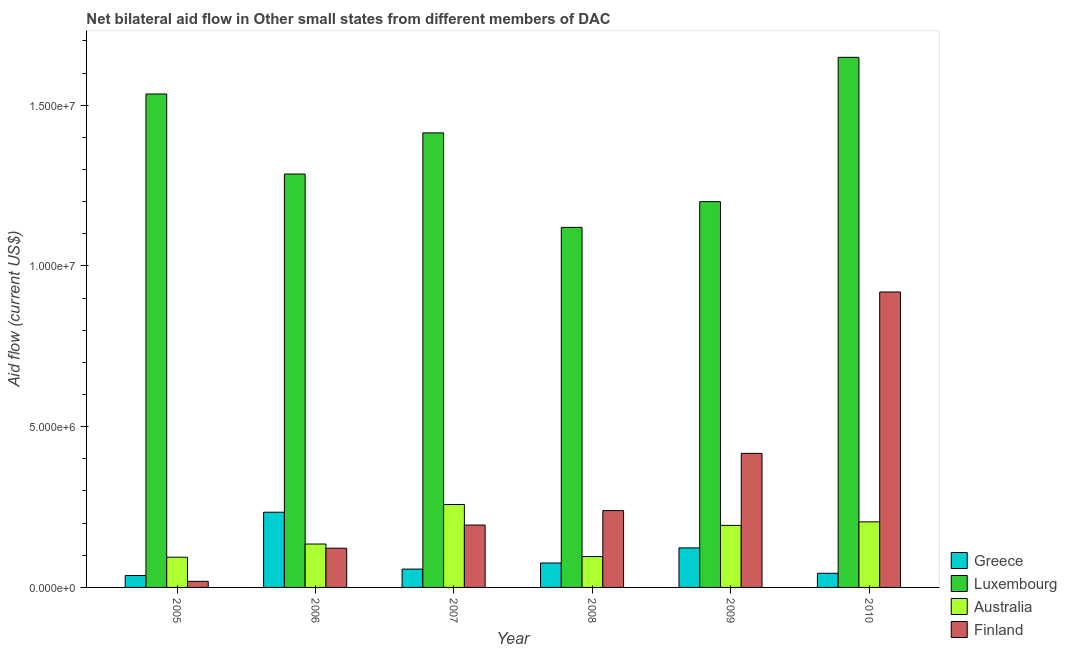How many different coloured bars are there?
Ensure brevity in your answer.  4. Are the number of bars per tick equal to the number of legend labels?
Provide a short and direct response. Yes. Are the number of bars on each tick of the X-axis equal?
Provide a succinct answer. Yes. How many bars are there on the 3rd tick from the left?
Ensure brevity in your answer.  4. How many bars are there on the 5th tick from the right?
Ensure brevity in your answer.  4. What is the label of the 4th group of bars from the left?
Keep it short and to the point. 2008. What is the amount of aid given by australia in 2009?
Provide a succinct answer. 1.93e+06. Across all years, what is the maximum amount of aid given by finland?
Your response must be concise. 9.19e+06. Across all years, what is the minimum amount of aid given by australia?
Offer a terse response. 9.40e+05. In which year was the amount of aid given by finland minimum?
Give a very brief answer. 2005. What is the total amount of aid given by finland in the graph?
Make the answer very short. 1.91e+07. What is the difference between the amount of aid given by finland in 2005 and that in 2010?
Your response must be concise. -9.00e+06. What is the difference between the amount of aid given by greece in 2005 and the amount of aid given by luxembourg in 2007?
Your answer should be compact. -2.00e+05. What is the average amount of aid given by finland per year?
Ensure brevity in your answer.  3.18e+06. What is the ratio of the amount of aid given by greece in 2008 to that in 2010?
Offer a terse response. 1.73. What is the difference between the highest and the second highest amount of aid given by greece?
Offer a terse response. 1.11e+06. What is the difference between the highest and the lowest amount of aid given by australia?
Make the answer very short. 1.64e+06. Is the sum of the amount of aid given by finland in 2006 and 2009 greater than the maximum amount of aid given by greece across all years?
Make the answer very short. No. What does the 2nd bar from the right in 2006 represents?
Your answer should be compact. Australia. What is the difference between two consecutive major ticks on the Y-axis?
Offer a very short reply. 5.00e+06. Are the values on the major ticks of Y-axis written in scientific E-notation?
Offer a terse response. Yes. Does the graph contain any zero values?
Your response must be concise. No. Where does the legend appear in the graph?
Your answer should be very brief. Bottom right. How many legend labels are there?
Your answer should be very brief. 4. How are the legend labels stacked?
Your answer should be very brief. Vertical. What is the title of the graph?
Offer a very short reply. Net bilateral aid flow in Other small states from different members of DAC. Does "Regional development banks" appear as one of the legend labels in the graph?
Make the answer very short. No. What is the label or title of the X-axis?
Make the answer very short. Year. What is the Aid flow (current US$) of Greece in 2005?
Your answer should be compact. 3.70e+05. What is the Aid flow (current US$) of Luxembourg in 2005?
Your response must be concise. 1.54e+07. What is the Aid flow (current US$) in Australia in 2005?
Your answer should be very brief. 9.40e+05. What is the Aid flow (current US$) in Finland in 2005?
Give a very brief answer. 1.90e+05. What is the Aid flow (current US$) in Greece in 2006?
Keep it short and to the point. 2.34e+06. What is the Aid flow (current US$) of Luxembourg in 2006?
Offer a very short reply. 1.29e+07. What is the Aid flow (current US$) of Australia in 2006?
Offer a terse response. 1.35e+06. What is the Aid flow (current US$) in Finland in 2006?
Offer a very short reply. 1.22e+06. What is the Aid flow (current US$) of Greece in 2007?
Your response must be concise. 5.70e+05. What is the Aid flow (current US$) in Luxembourg in 2007?
Provide a short and direct response. 1.41e+07. What is the Aid flow (current US$) in Australia in 2007?
Make the answer very short. 2.58e+06. What is the Aid flow (current US$) in Finland in 2007?
Provide a succinct answer. 1.94e+06. What is the Aid flow (current US$) of Greece in 2008?
Your response must be concise. 7.60e+05. What is the Aid flow (current US$) in Luxembourg in 2008?
Ensure brevity in your answer.  1.12e+07. What is the Aid flow (current US$) of Australia in 2008?
Your answer should be very brief. 9.60e+05. What is the Aid flow (current US$) of Finland in 2008?
Your answer should be very brief. 2.39e+06. What is the Aid flow (current US$) of Greece in 2009?
Offer a very short reply. 1.23e+06. What is the Aid flow (current US$) in Luxembourg in 2009?
Ensure brevity in your answer.  1.20e+07. What is the Aid flow (current US$) in Australia in 2009?
Keep it short and to the point. 1.93e+06. What is the Aid flow (current US$) in Finland in 2009?
Provide a short and direct response. 4.17e+06. What is the Aid flow (current US$) in Luxembourg in 2010?
Your answer should be compact. 1.65e+07. What is the Aid flow (current US$) in Australia in 2010?
Your answer should be compact. 2.04e+06. What is the Aid flow (current US$) of Finland in 2010?
Give a very brief answer. 9.19e+06. Across all years, what is the maximum Aid flow (current US$) in Greece?
Your response must be concise. 2.34e+06. Across all years, what is the maximum Aid flow (current US$) of Luxembourg?
Your answer should be very brief. 1.65e+07. Across all years, what is the maximum Aid flow (current US$) of Australia?
Offer a very short reply. 2.58e+06. Across all years, what is the maximum Aid flow (current US$) in Finland?
Provide a succinct answer. 9.19e+06. Across all years, what is the minimum Aid flow (current US$) of Greece?
Offer a terse response. 3.70e+05. Across all years, what is the minimum Aid flow (current US$) of Luxembourg?
Offer a very short reply. 1.12e+07. Across all years, what is the minimum Aid flow (current US$) in Australia?
Give a very brief answer. 9.40e+05. What is the total Aid flow (current US$) in Greece in the graph?
Provide a succinct answer. 5.71e+06. What is the total Aid flow (current US$) in Luxembourg in the graph?
Give a very brief answer. 8.20e+07. What is the total Aid flow (current US$) of Australia in the graph?
Your answer should be very brief. 9.80e+06. What is the total Aid flow (current US$) in Finland in the graph?
Your answer should be compact. 1.91e+07. What is the difference between the Aid flow (current US$) in Greece in 2005 and that in 2006?
Your answer should be compact. -1.97e+06. What is the difference between the Aid flow (current US$) of Luxembourg in 2005 and that in 2006?
Ensure brevity in your answer.  2.49e+06. What is the difference between the Aid flow (current US$) in Australia in 2005 and that in 2006?
Keep it short and to the point. -4.10e+05. What is the difference between the Aid flow (current US$) of Finland in 2005 and that in 2006?
Keep it short and to the point. -1.03e+06. What is the difference between the Aid flow (current US$) of Greece in 2005 and that in 2007?
Give a very brief answer. -2.00e+05. What is the difference between the Aid flow (current US$) of Luxembourg in 2005 and that in 2007?
Ensure brevity in your answer.  1.21e+06. What is the difference between the Aid flow (current US$) of Australia in 2005 and that in 2007?
Offer a terse response. -1.64e+06. What is the difference between the Aid flow (current US$) of Finland in 2005 and that in 2007?
Give a very brief answer. -1.75e+06. What is the difference between the Aid flow (current US$) in Greece in 2005 and that in 2008?
Ensure brevity in your answer.  -3.90e+05. What is the difference between the Aid flow (current US$) in Luxembourg in 2005 and that in 2008?
Keep it short and to the point. 4.15e+06. What is the difference between the Aid flow (current US$) in Finland in 2005 and that in 2008?
Your answer should be compact. -2.20e+06. What is the difference between the Aid flow (current US$) of Greece in 2005 and that in 2009?
Your answer should be compact. -8.60e+05. What is the difference between the Aid flow (current US$) of Luxembourg in 2005 and that in 2009?
Your answer should be compact. 3.35e+06. What is the difference between the Aid flow (current US$) of Australia in 2005 and that in 2009?
Your answer should be very brief. -9.90e+05. What is the difference between the Aid flow (current US$) in Finland in 2005 and that in 2009?
Provide a short and direct response. -3.98e+06. What is the difference between the Aid flow (current US$) of Greece in 2005 and that in 2010?
Provide a succinct answer. -7.00e+04. What is the difference between the Aid flow (current US$) of Luxembourg in 2005 and that in 2010?
Your answer should be very brief. -1.14e+06. What is the difference between the Aid flow (current US$) of Australia in 2005 and that in 2010?
Your answer should be compact. -1.10e+06. What is the difference between the Aid flow (current US$) of Finland in 2005 and that in 2010?
Ensure brevity in your answer.  -9.00e+06. What is the difference between the Aid flow (current US$) in Greece in 2006 and that in 2007?
Provide a short and direct response. 1.77e+06. What is the difference between the Aid flow (current US$) in Luxembourg in 2006 and that in 2007?
Make the answer very short. -1.28e+06. What is the difference between the Aid flow (current US$) of Australia in 2006 and that in 2007?
Your response must be concise. -1.23e+06. What is the difference between the Aid flow (current US$) of Finland in 2006 and that in 2007?
Give a very brief answer. -7.20e+05. What is the difference between the Aid flow (current US$) of Greece in 2006 and that in 2008?
Your response must be concise. 1.58e+06. What is the difference between the Aid flow (current US$) of Luxembourg in 2006 and that in 2008?
Your response must be concise. 1.66e+06. What is the difference between the Aid flow (current US$) in Finland in 2006 and that in 2008?
Your answer should be very brief. -1.17e+06. What is the difference between the Aid flow (current US$) in Greece in 2006 and that in 2009?
Make the answer very short. 1.11e+06. What is the difference between the Aid flow (current US$) of Luxembourg in 2006 and that in 2009?
Provide a short and direct response. 8.60e+05. What is the difference between the Aid flow (current US$) of Australia in 2006 and that in 2009?
Offer a terse response. -5.80e+05. What is the difference between the Aid flow (current US$) in Finland in 2006 and that in 2009?
Ensure brevity in your answer.  -2.95e+06. What is the difference between the Aid flow (current US$) of Greece in 2006 and that in 2010?
Your answer should be very brief. 1.90e+06. What is the difference between the Aid flow (current US$) in Luxembourg in 2006 and that in 2010?
Your answer should be very brief. -3.63e+06. What is the difference between the Aid flow (current US$) of Australia in 2006 and that in 2010?
Provide a short and direct response. -6.90e+05. What is the difference between the Aid flow (current US$) of Finland in 2006 and that in 2010?
Your response must be concise. -7.97e+06. What is the difference between the Aid flow (current US$) of Luxembourg in 2007 and that in 2008?
Keep it short and to the point. 2.94e+06. What is the difference between the Aid flow (current US$) of Australia in 2007 and that in 2008?
Offer a very short reply. 1.62e+06. What is the difference between the Aid flow (current US$) in Finland in 2007 and that in 2008?
Offer a terse response. -4.50e+05. What is the difference between the Aid flow (current US$) of Greece in 2007 and that in 2009?
Keep it short and to the point. -6.60e+05. What is the difference between the Aid flow (current US$) of Luxembourg in 2007 and that in 2009?
Ensure brevity in your answer.  2.14e+06. What is the difference between the Aid flow (current US$) of Australia in 2007 and that in 2009?
Give a very brief answer. 6.50e+05. What is the difference between the Aid flow (current US$) in Finland in 2007 and that in 2009?
Your response must be concise. -2.23e+06. What is the difference between the Aid flow (current US$) of Luxembourg in 2007 and that in 2010?
Your answer should be compact. -2.35e+06. What is the difference between the Aid flow (current US$) in Australia in 2007 and that in 2010?
Ensure brevity in your answer.  5.40e+05. What is the difference between the Aid flow (current US$) in Finland in 2007 and that in 2010?
Offer a terse response. -7.25e+06. What is the difference between the Aid flow (current US$) of Greece in 2008 and that in 2009?
Provide a short and direct response. -4.70e+05. What is the difference between the Aid flow (current US$) of Luxembourg in 2008 and that in 2009?
Keep it short and to the point. -8.00e+05. What is the difference between the Aid flow (current US$) in Australia in 2008 and that in 2009?
Your answer should be compact. -9.70e+05. What is the difference between the Aid flow (current US$) of Finland in 2008 and that in 2009?
Ensure brevity in your answer.  -1.78e+06. What is the difference between the Aid flow (current US$) in Luxembourg in 2008 and that in 2010?
Give a very brief answer. -5.29e+06. What is the difference between the Aid flow (current US$) of Australia in 2008 and that in 2010?
Your answer should be compact. -1.08e+06. What is the difference between the Aid flow (current US$) of Finland in 2008 and that in 2010?
Offer a very short reply. -6.80e+06. What is the difference between the Aid flow (current US$) in Greece in 2009 and that in 2010?
Your answer should be compact. 7.90e+05. What is the difference between the Aid flow (current US$) in Luxembourg in 2009 and that in 2010?
Offer a very short reply. -4.49e+06. What is the difference between the Aid flow (current US$) of Australia in 2009 and that in 2010?
Offer a very short reply. -1.10e+05. What is the difference between the Aid flow (current US$) in Finland in 2009 and that in 2010?
Make the answer very short. -5.02e+06. What is the difference between the Aid flow (current US$) in Greece in 2005 and the Aid flow (current US$) in Luxembourg in 2006?
Your answer should be very brief. -1.25e+07. What is the difference between the Aid flow (current US$) in Greece in 2005 and the Aid flow (current US$) in Australia in 2006?
Ensure brevity in your answer.  -9.80e+05. What is the difference between the Aid flow (current US$) in Greece in 2005 and the Aid flow (current US$) in Finland in 2006?
Offer a terse response. -8.50e+05. What is the difference between the Aid flow (current US$) of Luxembourg in 2005 and the Aid flow (current US$) of Australia in 2006?
Provide a short and direct response. 1.40e+07. What is the difference between the Aid flow (current US$) in Luxembourg in 2005 and the Aid flow (current US$) in Finland in 2006?
Ensure brevity in your answer.  1.41e+07. What is the difference between the Aid flow (current US$) in Australia in 2005 and the Aid flow (current US$) in Finland in 2006?
Provide a short and direct response. -2.80e+05. What is the difference between the Aid flow (current US$) in Greece in 2005 and the Aid flow (current US$) in Luxembourg in 2007?
Offer a terse response. -1.38e+07. What is the difference between the Aid flow (current US$) in Greece in 2005 and the Aid flow (current US$) in Australia in 2007?
Provide a short and direct response. -2.21e+06. What is the difference between the Aid flow (current US$) of Greece in 2005 and the Aid flow (current US$) of Finland in 2007?
Ensure brevity in your answer.  -1.57e+06. What is the difference between the Aid flow (current US$) in Luxembourg in 2005 and the Aid flow (current US$) in Australia in 2007?
Make the answer very short. 1.28e+07. What is the difference between the Aid flow (current US$) in Luxembourg in 2005 and the Aid flow (current US$) in Finland in 2007?
Provide a succinct answer. 1.34e+07. What is the difference between the Aid flow (current US$) in Greece in 2005 and the Aid flow (current US$) in Luxembourg in 2008?
Give a very brief answer. -1.08e+07. What is the difference between the Aid flow (current US$) in Greece in 2005 and the Aid flow (current US$) in Australia in 2008?
Give a very brief answer. -5.90e+05. What is the difference between the Aid flow (current US$) of Greece in 2005 and the Aid flow (current US$) of Finland in 2008?
Provide a succinct answer. -2.02e+06. What is the difference between the Aid flow (current US$) in Luxembourg in 2005 and the Aid flow (current US$) in Australia in 2008?
Provide a succinct answer. 1.44e+07. What is the difference between the Aid flow (current US$) of Luxembourg in 2005 and the Aid flow (current US$) of Finland in 2008?
Keep it short and to the point. 1.30e+07. What is the difference between the Aid flow (current US$) of Australia in 2005 and the Aid flow (current US$) of Finland in 2008?
Provide a short and direct response. -1.45e+06. What is the difference between the Aid flow (current US$) in Greece in 2005 and the Aid flow (current US$) in Luxembourg in 2009?
Your answer should be compact. -1.16e+07. What is the difference between the Aid flow (current US$) in Greece in 2005 and the Aid flow (current US$) in Australia in 2009?
Your answer should be very brief. -1.56e+06. What is the difference between the Aid flow (current US$) in Greece in 2005 and the Aid flow (current US$) in Finland in 2009?
Offer a terse response. -3.80e+06. What is the difference between the Aid flow (current US$) in Luxembourg in 2005 and the Aid flow (current US$) in Australia in 2009?
Keep it short and to the point. 1.34e+07. What is the difference between the Aid flow (current US$) in Luxembourg in 2005 and the Aid flow (current US$) in Finland in 2009?
Keep it short and to the point. 1.12e+07. What is the difference between the Aid flow (current US$) in Australia in 2005 and the Aid flow (current US$) in Finland in 2009?
Offer a terse response. -3.23e+06. What is the difference between the Aid flow (current US$) of Greece in 2005 and the Aid flow (current US$) of Luxembourg in 2010?
Offer a very short reply. -1.61e+07. What is the difference between the Aid flow (current US$) in Greece in 2005 and the Aid flow (current US$) in Australia in 2010?
Your response must be concise. -1.67e+06. What is the difference between the Aid flow (current US$) of Greece in 2005 and the Aid flow (current US$) of Finland in 2010?
Your response must be concise. -8.82e+06. What is the difference between the Aid flow (current US$) of Luxembourg in 2005 and the Aid flow (current US$) of Australia in 2010?
Keep it short and to the point. 1.33e+07. What is the difference between the Aid flow (current US$) in Luxembourg in 2005 and the Aid flow (current US$) in Finland in 2010?
Keep it short and to the point. 6.16e+06. What is the difference between the Aid flow (current US$) in Australia in 2005 and the Aid flow (current US$) in Finland in 2010?
Offer a very short reply. -8.25e+06. What is the difference between the Aid flow (current US$) of Greece in 2006 and the Aid flow (current US$) of Luxembourg in 2007?
Offer a very short reply. -1.18e+07. What is the difference between the Aid flow (current US$) of Greece in 2006 and the Aid flow (current US$) of Australia in 2007?
Your response must be concise. -2.40e+05. What is the difference between the Aid flow (current US$) of Greece in 2006 and the Aid flow (current US$) of Finland in 2007?
Ensure brevity in your answer.  4.00e+05. What is the difference between the Aid flow (current US$) in Luxembourg in 2006 and the Aid flow (current US$) in Australia in 2007?
Provide a short and direct response. 1.03e+07. What is the difference between the Aid flow (current US$) of Luxembourg in 2006 and the Aid flow (current US$) of Finland in 2007?
Offer a terse response. 1.09e+07. What is the difference between the Aid flow (current US$) of Australia in 2006 and the Aid flow (current US$) of Finland in 2007?
Keep it short and to the point. -5.90e+05. What is the difference between the Aid flow (current US$) of Greece in 2006 and the Aid flow (current US$) of Luxembourg in 2008?
Keep it short and to the point. -8.86e+06. What is the difference between the Aid flow (current US$) in Greece in 2006 and the Aid flow (current US$) in Australia in 2008?
Give a very brief answer. 1.38e+06. What is the difference between the Aid flow (current US$) of Greece in 2006 and the Aid flow (current US$) of Finland in 2008?
Provide a short and direct response. -5.00e+04. What is the difference between the Aid flow (current US$) of Luxembourg in 2006 and the Aid flow (current US$) of Australia in 2008?
Make the answer very short. 1.19e+07. What is the difference between the Aid flow (current US$) in Luxembourg in 2006 and the Aid flow (current US$) in Finland in 2008?
Make the answer very short. 1.05e+07. What is the difference between the Aid flow (current US$) of Australia in 2006 and the Aid flow (current US$) of Finland in 2008?
Provide a short and direct response. -1.04e+06. What is the difference between the Aid flow (current US$) in Greece in 2006 and the Aid flow (current US$) in Luxembourg in 2009?
Offer a very short reply. -9.66e+06. What is the difference between the Aid flow (current US$) of Greece in 2006 and the Aid flow (current US$) of Australia in 2009?
Ensure brevity in your answer.  4.10e+05. What is the difference between the Aid flow (current US$) of Greece in 2006 and the Aid flow (current US$) of Finland in 2009?
Ensure brevity in your answer.  -1.83e+06. What is the difference between the Aid flow (current US$) of Luxembourg in 2006 and the Aid flow (current US$) of Australia in 2009?
Offer a terse response. 1.09e+07. What is the difference between the Aid flow (current US$) in Luxembourg in 2006 and the Aid flow (current US$) in Finland in 2009?
Ensure brevity in your answer.  8.69e+06. What is the difference between the Aid flow (current US$) of Australia in 2006 and the Aid flow (current US$) of Finland in 2009?
Your answer should be compact. -2.82e+06. What is the difference between the Aid flow (current US$) in Greece in 2006 and the Aid flow (current US$) in Luxembourg in 2010?
Your answer should be compact. -1.42e+07. What is the difference between the Aid flow (current US$) in Greece in 2006 and the Aid flow (current US$) in Finland in 2010?
Your answer should be very brief. -6.85e+06. What is the difference between the Aid flow (current US$) of Luxembourg in 2006 and the Aid flow (current US$) of Australia in 2010?
Give a very brief answer. 1.08e+07. What is the difference between the Aid flow (current US$) in Luxembourg in 2006 and the Aid flow (current US$) in Finland in 2010?
Ensure brevity in your answer.  3.67e+06. What is the difference between the Aid flow (current US$) of Australia in 2006 and the Aid flow (current US$) of Finland in 2010?
Provide a short and direct response. -7.84e+06. What is the difference between the Aid flow (current US$) in Greece in 2007 and the Aid flow (current US$) in Luxembourg in 2008?
Make the answer very short. -1.06e+07. What is the difference between the Aid flow (current US$) of Greece in 2007 and the Aid flow (current US$) of Australia in 2008?
Your response must be concise. -3.90e+05. What is the difference between the Aid flow (current US$) of Greece in 2007 and the Aid flow (current US$) of Finland in 2008?
Keep it short and to the point. -1.82e+06. What is the difference between the Aid flow (current US$) in Luxembourg in 2007 and the Aid flow (current US$) in Australia in 2008?
Your answer should be very brief. 1.32e+07. What is the difference between the Aid flow (current US$) in Luxembourg in 2007 and the Aid flow (current US$) in Finland in 2008?
Your answer should be compact. 1.18e+07. What is the difference between the Aid flow (current US$) in Australia in 2007 and the Aid flow (current US$) in Finland in 2008?
Keep it short and to the point. 1.90e+05. What is the difference between the Aid flow (current US$) of Greece in 2007 and the Aid flow (current US$) of Luxembourg in 2009?
Give a very brief answer. -1.14e+07. What is the difference between the Aid flow (current US$) of Greece in 2007 and the Aid flow (current US$) of Australia in 2009?
Offer a very short reply. -1.36e+06. What is the difference between the Aid flow (current US$) in Greece in 2007 and the Aid flow (current US$) in Finland in 2009?
Keep it short and to the point. -3.60e+06. What is the difference between the Aid flow (current US$) in Luxembourg in 2007 and the Aid flow (current US$) in Australia in 2009?
Your response must be concise. 1.22e+07. What is the difference between the Aid flow (current US$) in Luxembourg in 2007 and the Aid flow (current US$) in Finland in 2009?
Your answer should be compact. 9.97e+06. What is the difference between the Aid flow (current US$) in Australia in 2007 and the Aid flow (current US$) in Finland in 2009?
Offer a terse response. -1.59e+06. What is the difference between the Aid flow (current US$) of Greece in 2007 and the Aid flow (current US$) of Luxembourg in 2010?
Keep it short and to the point. -1.59e+07. What is the difference between the Aid flow (current US$) of Greece in 2007 and the Aid flow (current US$) of Australia in 2010?
Your answer should be compact. -1.47e+06. What is the difference between the Aid flow (current US$) of Greece in 2007 and the Aid flow (current US$) of Finland in 2010?
Give a very brief answer. -8.62e+06. What is the difference between the Aid flow (current US$) in Luxembourg in 2007 and the Aid flow (current US$) in Australia in 2010?
Keep it short and to the point. 1.21e+07. What is the difference between the Aid flow (current US$) in Luxembourg in 2007 and the Aid flow (current US$) in Finland in 2010?
Offer a very short reply. 4.95e+06. What is the difference between the Aid flow (current US$) of Australia in 2007 and the Aid flow (current US$) of Finland in 2010?
Give a very brief answer. -6.61e+06. What is the difference between the Aid flow (current US$) of Greece in 2008 and the Aid flow (current US$) of Luxembourg in 2009?
Give a very brief answer. -1.12e+07. What is the difference between the Aid flow (current US$) of Greece in 2008 and the Aid flow (current US$) of Australia in 2009?
Your answer should be compact. -1.17e+06. What is the difference between the Aid flow (current US$) in Greece in 2008 and the Aid flow (current US$) in Finland in 2009?
Make the answer very short. -3.41e+06. What is the difference between the Aid flow (current US$) of Luxembourg in 2008 and the Aid flow (current US$) of Australia in 2009?
Give a very brief answer. 9.27e+06. What is the difference between the Aid flow (current US$) in Luxembourg in 2008 and the Aid flow (current US$) in Finland in 2009?
Provide a succinct answer. 7.03e+06. What is the difference between the Aid flow (current US$) of Australia in 2008 and the Aid flow (current US$) of Finland in 2009?
Give a very brief answer. -3.21e+06. What is the difference between the Aid flow (current US$) in Greece in 2008 and the Aid flow (current US$) in Luxembourg in 2010?
Provide a succinct answer. -1.57e+07. What is the difference between the Aid flow (current US$) of Greece in 2008 and the Aid flow (current US$) of Australia in 2010?
Keep it short and to the point. -1.28e+06. What is the difference between the Aid flow (current US$) of Greece in 2008 and the Aid flow (current US$) of Finland in 2010?
Provide a short and direct response. -8.43e+06. What is the difference between the Aid flow (current US$) in Luxembourg in 2008 and the Aid flow (current US$) in Australia in 2010?
Your answer should be very brief. 9.16e+06. What is the difference between the Aid flow (current US$) of Luxembourg in 2008 and the Aid flow (current US$) of Finland in 2010?
Offer a terse response. 2.01e+06. What is the difference between the Aid flow (current US$) of Australia in 2008 and the Aid flow (current US$) of Finland in 2010?
Provide a succinct answer. -8.23e+06. What is the difference between the Aid flow (current US$) in Greece in 2009 and the Aid flow (current US$) in Luxembourg in 2010?
Make the answer very short. -1.53e+07. What is the difference between the Aid flow (current US$) in Greece in 2009 and the Aid flow (current US$) in Australia in 2010?
Provide a short and direct response. -8.10e+05. What is the difference between the Aid flow (current US$) in Greece in 2009 and the Aid flow (current US$) in Finland in 2010?
Ensure brevity in your answer.  -7.96e+06. What is the difference between the Aid flow (current US$) in Luxembourg in 2009 and the Aid flow (current US$) in Australia in 2010?
Your answer should be compact. 9.96e+06. What is the difference between the Aid flow (current US$) of Luxembourg in 2009 and the Aid flow (current US$) of Finland in 2010?
Offer a terse response. 2.81e+06. What is the difference between the Aid flow (current US$) in Australia in 2009 and the Aid flow (current US$) in Finland in 2010?
Offer a very short reply. -7.26e+06. What is the average Aid flow (current US$) of Greece per year?
Provide a succinct answer. 9.52e+05. What is the average Aid flow (current US$) in Luxembourg per year?
Offer a terse response. 1.37e+07. What is the average Aid flow (current US$) in Australia per year?
Your answer should be compact. 1.63e+06. What is the average Aid flow (current US$) in Finland per year?
Give a very brief answer. 3.18e+06. In the year 2005, what is the difference between the Aid flow (current US$) in Greece and Aid flow (current US$) in Luxembourg?
Your answer should be very brief. -1.50e+07. In the year 2005, what is the difference between the Aid flow (current US$) in Greece and Aid flow (current US$) in Australia?
Give a very brief answer. -5.70e+05. In the year 2005, what is the difference between the Aid flow (current US$) in Greece and Aid flow (current US$) in Finland?
Keep it short and to the point. 1.80e+05. In the year 2005, what is the difference between the Aid flow (current US$) of Luxembourg and Aid flow (current US$) of Australia?
Your answer should be compact. 1.44e+07. In the year 2005, what is the difference between the Aid flow (current US$) in Luxembourg and Aid flow (current US$) in Finland?
Your answer should be very brief. 1.52e+07. In the year 2005, what is the difference between the Aid flow (current US$) of Australia and Aid flow (current US$) of Finland?
Provide a short and direct response. 7.50e+05. In the year 2006, what is the difference between the Aid flow (current US$) in Greece and Aid flow (current US$) in Luxembourg?
Your answer should be compact. -1.05e+07. In the year 2006, what is the difference between the Aid flow (current US$) of Greece and Aid flow (current US$) of Australia?
Give a very brief answer. 9.90e+05. In the year 2006, what is the difference between the Aid flow (current US$) of Greece and Aid flow (current US$) of Finland?
Make the answer very short. 1.12e+06. In the year 2006, what is the difference between the Aid flow (current US$) in Luxembourg and Aid flow (current US$) in Australia?
Offer a terse response. 1.15e+07. In the year 2006, what is the difference between the Aid flow (current US$) in Luxembourg and Aid flow (current US$) in Finland?
Your response must be concise. 1.16e+07. In the year 2006, what is the difference between the Aid flow (current US$) of Australia and Aid flow (current US$) of Finland?
Offer a very short reply. 1.30e+05. In the year 2007, what is the difference between the Aid flow (current US$) of Greece and Aid flow (current US$) of Luxembourg?
Offer a very short reply. -1.36e+07. In the year 2007, what is the difference between the Aid flow (current US$) of Greece and Aid flow (current US$) of Australia?
Ensure brevity in your answer.  -2.01e+06. In the year 2007, what is the difference between the Aid flow (current US$) in Greece and Aid flow (current US$) in Finland?
Your answer should be compact. -1.37e+06. In the year 2007, what is the difference between the Aid flow (current US$) of Luxembourg and Aid flow (current US$) of Australia?
Offer a very short reply. 1.16e+07. In the year 2007, what is the difference between the Aid flow (current US$) in Luxembourg and Aid flow (current US$) in Finland?
Offer a very short reply. 1.22e+07. In the year 2007, what is the difference between the Aid flow (current US$) in Australia and Aid flow (current US$) in Finland?
Offer a very short reply. 6.40e+05. In the year 2008, what is the difference between the Aid flow (current US$) of Greece and Aid flow (current US$) of Luxembourg?
Provide a succinct answer. -1.04e+07. In the year 2008, what is the difference between the Aid flow (current US$) in Greece and Aid flow (current US$) in Australia?
Provide a short and direct response. -2.00e+05. In the year 2008, what is the difference between the Aid flow (current US$) in Greece and Aid flow (current US$) in Finland?
Offer a terse response. -1.63e+06. In the year 2008, what is the difference between the Aid flow (current US$) in Luxembourg and Aid flow (current US$) in Australia?
Ensure brevity in your answer.  1.02e+07. In the year 2008, what is the difference between the Aid flow (current US$) of Luxembourg and Aid flow (current US$) of Finland?
Ensure brevity in your answer.  8.81e+06. In the year 2008, what is the difference between the Aid flow (current US$) of Australia and Aid flow (current US$) of Finland?
Keep it short and to the point. -1.43e+06. In the year 2009, what is the difference between the Aid flow (current US$) of Greece and Aid flow (current US$) of Luxembourg?
Your answer should be compact. -1.08e+07. In the year 2009, what is the difference between the Aid flow (current US$) in Greece and Aid flow (current US$) in Australia?
Offer a very short reply. -7.00e+05. In the year 2009, what is the difference between the Aid flow (current US$) in Greece and Aid flow (current US$) in Finland?
Offer a very short reply. -2.94e+06. In the year 2009, what is the difference between the Aid flow (current US$) of Luxembourg and Aid flow (current US$) of Australia?
Provide a succinct answer. 1.01e+07. In the year 2009, what is the difference between the Aid flow (current US$) in Luxembourg and Aid flow (current US$) in Finland?
Provide a short and direct response. 7.83e+06. In the year 2009, what is the difference between the Aid flow (current US$) in Australia and Aid flow (current US$) in Finland?
Keep it short and to the point. -2.24e+06. In the year 2010, what is the difference between the Aid flow (current US$) in Greece and Aid flow (current US$) in Luxembourg?
Provide a succinct answer. -1.60e+07. In the year 2010, what is the difference between the Aid flow (current US$) of Greece and Aid flow (current US$) of Australia?
Provide a short and direct response. -1.60e+06. In the year 2010, what is the difference between the Aid flow (current US$) of Greece and Aid flow (current US$) of Finland?
Ensure brevity in your answer.  -8.75e+06. In the year 2010, what is the difference between the Aid flow (current US$) of Luxembourg and Aid flow (current US$) of Australia?
Give a very brief answer. 1.44e+07. In the year 2010, what is the difference between the Aid flow (current US$) in Luxembourg and Aid flow (current US$) in Finland?
Keep it short and to the point. 7.30e+06. In the year 2010, what is the difference between the Aid flow (current US$) of Australia and Aid flow (current US$) of Finland?
Your response must be concise. -7.15e+06. What is the ratio of the Aid flow (current US$) in Greece in 2005 to that in 2006?
Your answer should be very brief. 0.16. What is the ratio of the Aid flow (current US$) of Luxembourg in 2005 to that in 2006?
Offer a very short reply. 1.19. What is the ratio of the Aid flow (current US$) of Australia in 2005 to that in 2006?
Give a very brief answer. 0.7. What is the ratio of the Aid flow (current US$) of Finland in 2005 to that in 2006?
Your response must be concise. 0.16. What is the ratio of the Aid flow (current US$) of Greece in 2005 to that in 2007?
Your answer should be compact. 0.65. What is the ratio of the Aid flow (current US$) of Luxembourg in 2005 to that in 2007?
Keep it short and to the point. 1.09. What is the ratio of the Aid flow (current US$) in Australia in 2005 to that in 2007?
Provide a succinct answer. 0.36. What is the ratio of the Aid flow (current US$) of Finland in 2005 to that in 2007?
Keep it short and to the point. 0.1. What is the ratio of the Aid flow (current US$) of Greece in 2005 to that in 2008?
Your response must be concise. 0.49. What is the ratio of the Aid flow (current US$) in Luxembourg in 2005 to that in 2008?
Offer a terse response. 1.37. What is the ratio of the Aid flow (current US$) in Australia in 2005 to that in 2008?
Your answer should be very brief. 0.98. What is the ratio of the Aid flow (current US$) in Finland in 2005 to that in 2008?
Offer a terse response. 0.08. What is the ratio of the Aid flow (current US$) in Greece in 2005 to that in 2009?
Give a very brief answer. 0.3. What is the ratio of the Aid flow (current US$) in Luxembourg in 2005 to that in 2009?
Your answer should be compact. 1.28. What is the ratio of the Aid flow (current US$) of Australia in 2005 to that in 2009?
Keep it short and to the point. 0.49. What is the ratio of the Aid flow (current US$) of Finland in 2005 to that in 2009?
Keep it short and to the point. 0.05. What is the ratio of the Aid flow (current US$) of Greece in 2005 to that in 2010?
Your answer should be compact. 0.84. What is the ratio of the Aid flow (current US$) of Luxembourg in 2005 to that in 2010?
Your response must be concise. 0.93. What is the ratio of the Aid flow (current US$) in Australia in 2005 to that in 2010?
Your answer should be very brief. 0.46. What is the ratio of the Aid flow (current US$) in Finland in 2005 to that in 2010?
Keep it short and to the point. 0.02. What is the ratio of the Aid flow (current US$) of Greece in 2006 to that in 2007?
Your response must be concise. 4.11. What is the ratio of the Aid flow (current US$) of Luxembourg in 2006 to that in 2007?
Your response must be concise. 0.91. What is the ratio of the Aid flow (current US$) of Australia in 2006 to that in 2007?
Your response must be concise. 0.52. What is the ratio of the Aid flow (current US$) of Finland in 2006 to that in 2007?
Your response must be concise. 0.63. What is the ratio of the Aid flow (current US$) in Greece in 2006 to that in 2008?
Keep it short and to the point. 3.08. What is the ratio of the Aid flow (current US$) of Luxembourg in 2006 to that in 2008?
Make the answer very short. 1.15. What is the ratio of the Aid flow (current US$) of Australia in 2006 to that in 2008?
Your response must be concise. 1.41. What is the ratio of the Aid flow (current US$) in Finland in 2006 to that in 2008?
Offer a terse response. 0.51. What is the ratio of the Aid flow (current US$) in Greece in 2006 to that in 2009?
Your response must be concise. 1.9. What is the ratio of the Aid flow (current US$) in Luxembourg in 2006 to that in 2009?
Your answer should be compact. 1.07. What is the ratio of the Aid flow (current US$) in Australia in 2006 to that in 2009?
Your answer should be very brief. 0.7. What is the ratio of the Aid flow (current US$) of Finland in 2006 to that in 2009?
Keep it short and to the point. 0.29. What is the ratio of the Aid flow (current US$) of Greece in 2006 to that in 2010?
Your response must be concise. 5.32. What is the ratio of the Aid flow (current US$) in Luxembourg in 2006 to that in 2010?
Keep it short and to the point. 0.78. What is the ratio of the Aid flow (current US$) in Australia in 2006 to that in 2010?
Your answer should be very brief. 0.66. What is the ratio of the Aid flow (current US$) of Finland in 2006 to that in 2010?
Provide a succinct answer. 0.13. What is the ratio of the Aid flow (current US$) in Luxembourg in 2007 to that in 2008?
Provide a succinct answer. 1.26. What is the ratio of the Aid flow (current US$) of Australia in 2007 to that in 2008?
Give a very brief answer. 2.69. What is the ratio of the Aid flow (current US$) in Finland in 2007 to that in 2008?
Your response must be concise. 0.81. What is the ratio of the Aid flow (current US$) in Greece in 2007 to that in 2009?
Your answer should be very brief. 0.46. What is the ratio of the Aid flow (current US$) of Luxembourg in 2007 to that in 2009?
Provide a succinct answer. 1.18. What is the ratio of the Aid flow (current US$) in Australia in 2007 to that in 2009?
Your answer should be very brief. 1.34. What is the ratio of the Aid flow (current US$) of Finland in 2007 to that in 2009?
Make the answer very short. 0.47. What is the ratio of the Aid flow (current US$) in Greece in 2007 to that in 2010?
Ensure brevity in your answer.  1.3. What is the ratio of the Aid flow (current US$) in Luxembourg in 2007 to that in 2010?
Keep it short and to the point. 0.86. What is the ratio of the Aid flow (current US$) of Australia in 2007 to that in 2010?
Offer a terse response. 1.26. What is the ratio of the Aid flow (current US$) in Finland in 2007 to that in 2010?
Provide a short and direct response. 0.21. What is the ratio of the Aid flow (current US$) in Greece in 2008 to that in 2009?
Provide a succinct answer. 0.62. What is the ratio of the Aid flow (current US$) of Australia in 2008 to that in 2009?
Your answer should be compact. 0.5. What is the ratio of the Aid flow (current US$) in Finland in 2008 to that in 2009?
Offer a very short reply. 0.57. What is the ratio of the Aid flow (current US$) of Greece in 2008 to that in 2010?
Your response must be concise. 1.73. What is the ratio of the Aid flow (current US$) in Luxembourg in 2008 to that in 2010?
Ensure brevity in your answer.  0.68. What is the ratio of the Aid flow (current US$) of Australia in 2008 to that in 2010?
Offer a terse response. 0.47. What is the ratio of the Aid flow (current US$) of Finland in 2008 to that in 2010?
Provide a succinct answer. 0.26. What is the ratio of the Aid flow (current US$) in Greece in 2009 to that in 2010?
Keep it short and to the point. 2.8. What is the ratio of the Aid flow (current US$) in Luxembourg in 2009 to that in 2010?
Make the answer very short. 0.73. What is the ratio of the Aid flow (current US$) in Australia in 2009 to that in 2010?
Give a very brief answer. 0.95. What is the ratio of the Aid flow (current US$) of Finland in 2009 to that in 2010?
Offer a very short reply. 0.45. What is the difference between the highest and the second highest Aid flow (current US$) of Greece?
Provide a succinct answer. 1.11e+06. What is the difference between the highest and the second highest Aid flow (current US$) in Luxembourg?
Ensure brevity in your answer.  1.14e+06. What is the difference between the highest and the second highest Aid flow (current US$) in Australia?
Provide a short and direct response. 5.40e+05. What is the difference between the highest and the second highest Aid flow (current US$) in Finland?
Make the answer very short. 5.02e+06. What is the difference between the highest and the lowest Aid flow (current US$) in Greece?
Your answer should be very brief. 1.97e+06. What is the difference between the highest and the lowest Aid flow (current US$) of Luxembourg?
Give a very brief answer. 5.29e+06. What is the difference between the highest and the lowest Aid flow (current US$) of Australia?
Keep it short and to the point. 1.64e+06. What is the difference between the highest and the lowest Aid flow (current US$) of Finland?
Provide a short and direct response. 9.00e+06. 